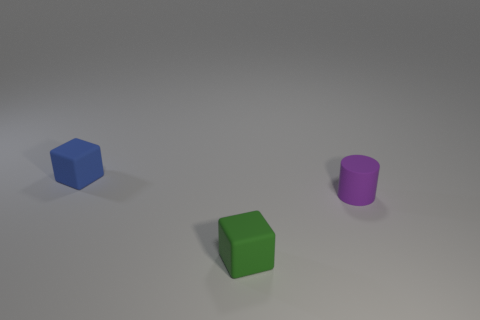Add 1 small green things. How many objects exist? 4 Subtract all cylinders. How many objects are left? 2 Add 2 green rubber blocks. How many green rubber blocks are left? 3 Add 2 tiny rubber things. How many tiny rubber things exist? 5 Subtract 0 green cylinders. How many objects are left? 3 Subtract all tiny gray metallic balls. Subtract all tiny green blocks. How many objects are left? 2 